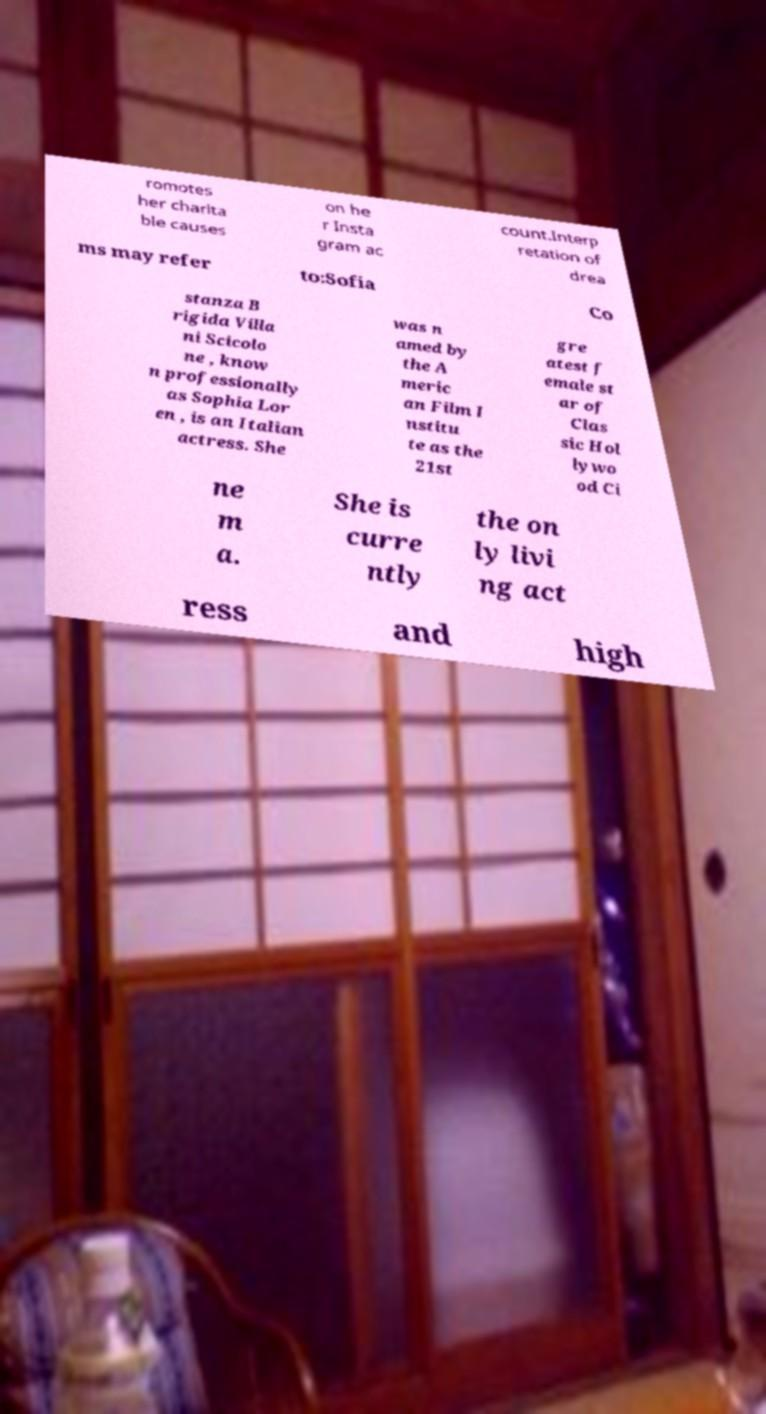For documentation purposes, I need the text within this image transcribed. Could you provide that? romotes her charita ble causes on he r Insta gram ac count.Interp retation of drea ms may refer to:Sofia Co stanza B rigida Villa ni Scicolo ne , know n professionally as Sophia Lor en , is an Italian actress. She was n amed by the A meric an Film I nstitu te as the 21st gre atest f emale st ar of Clas sic Hol lywo od Ci ne m a. She is curre ntly the on ly livi ng act ress and high 